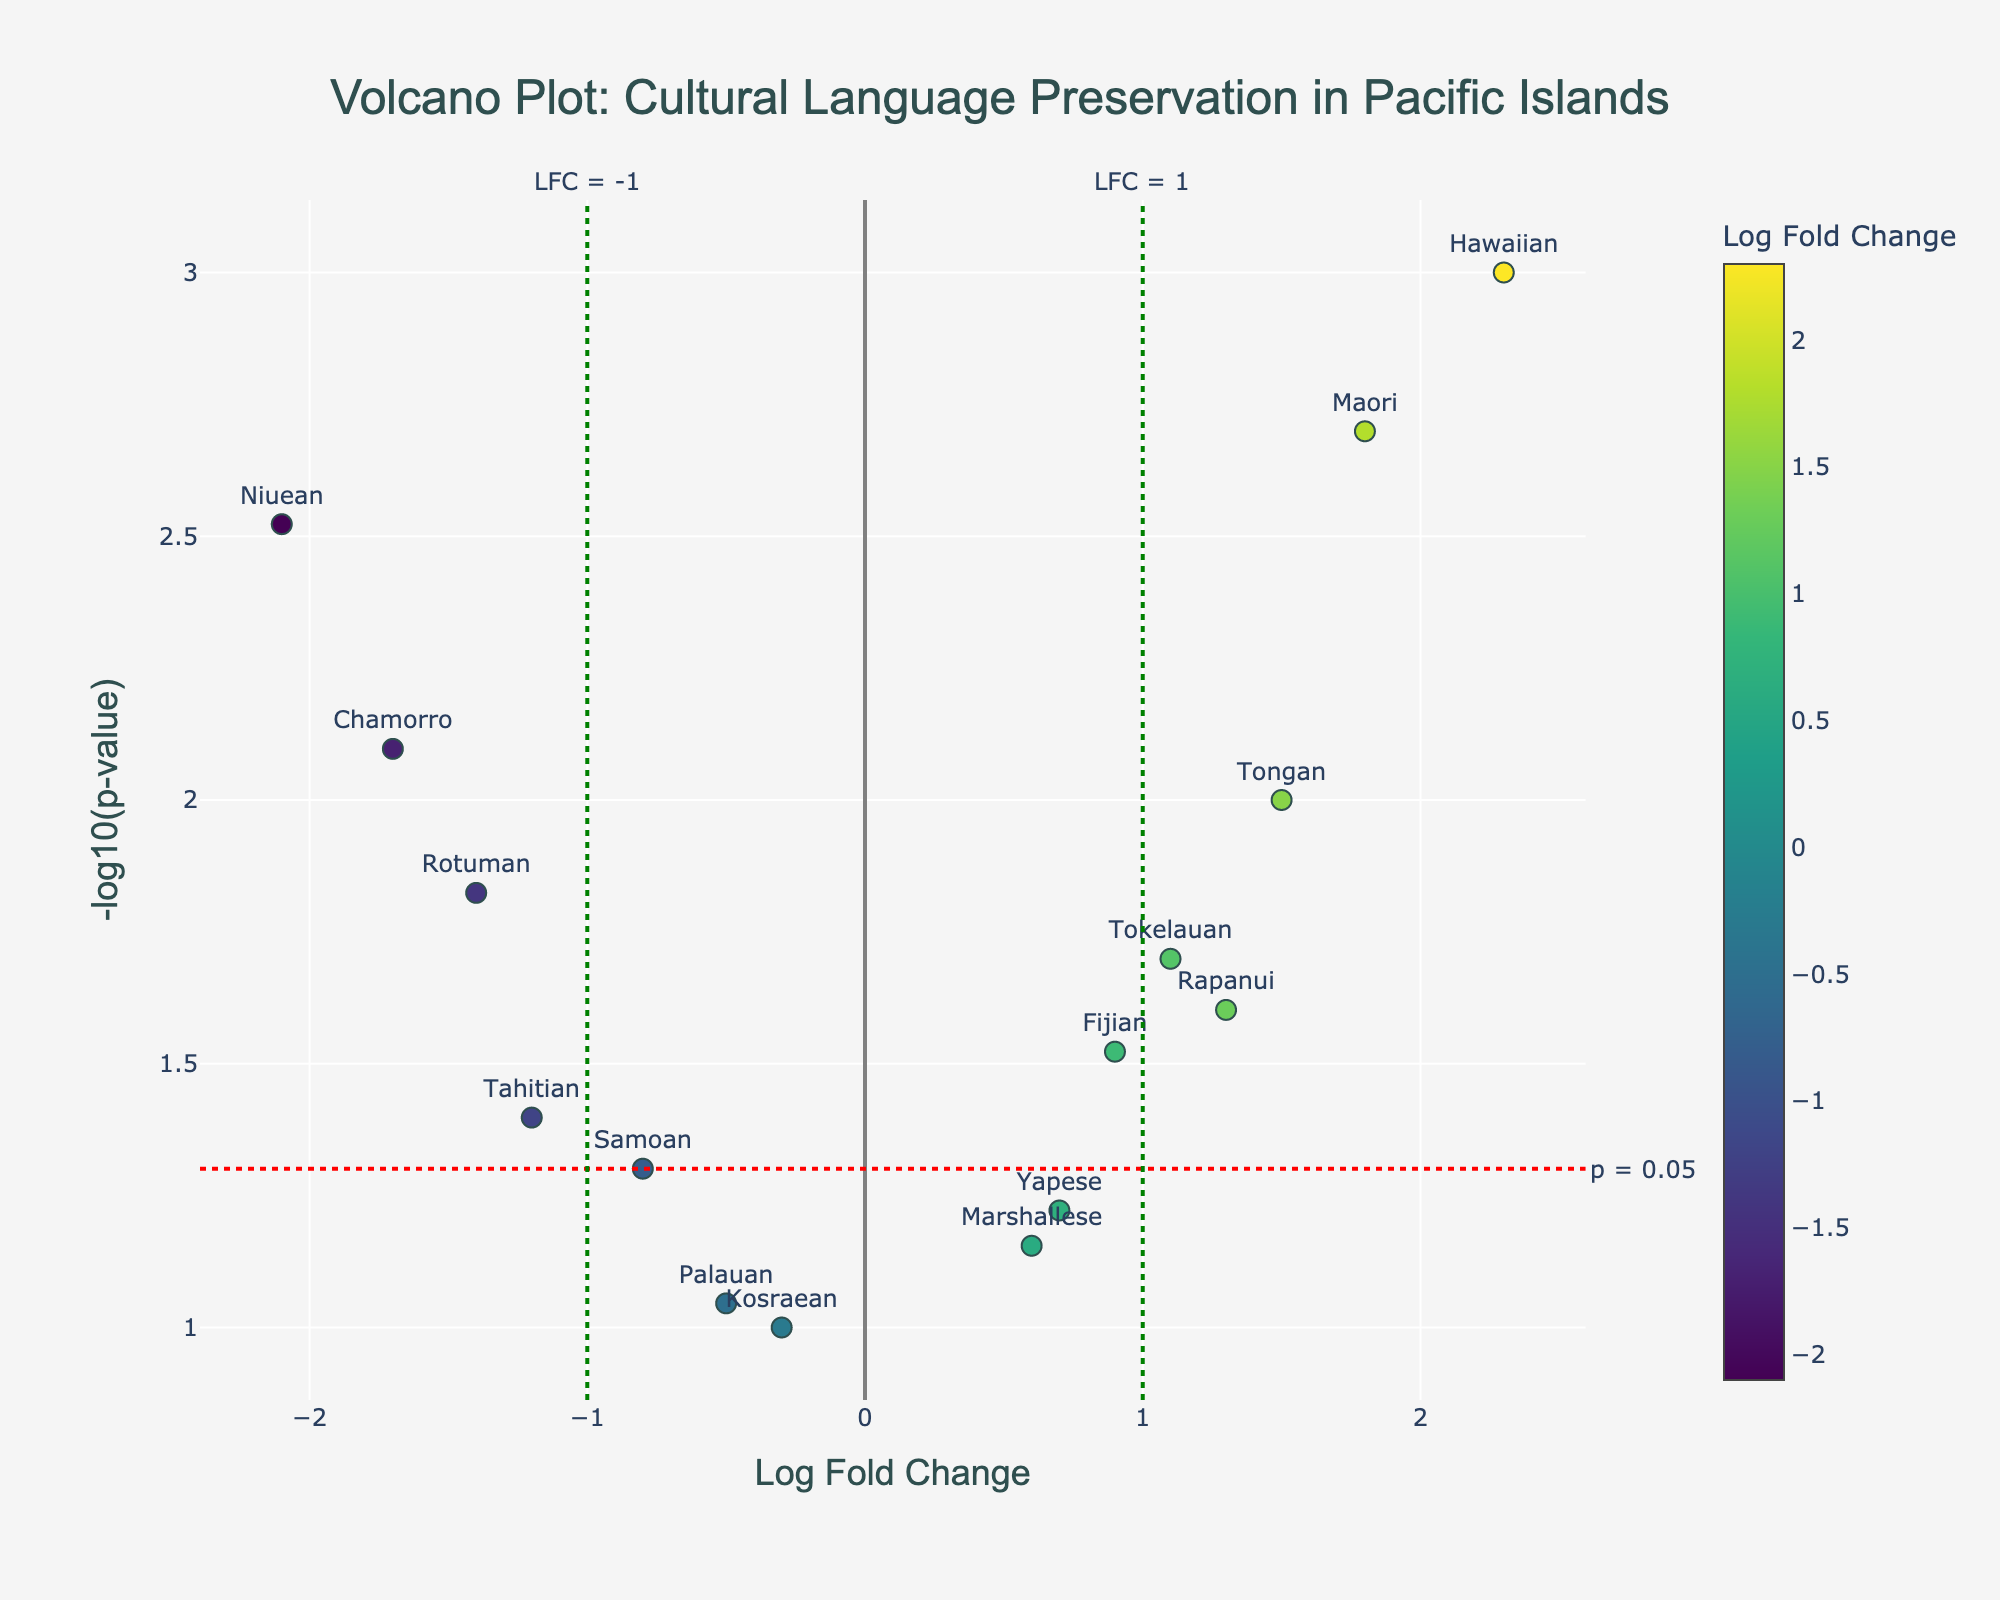What does the title of the plot say? The title of the plot is located at the top center of the figure in large, bold text. It provides a summary of what the plot is about. In this case, it tells us the plot represents "Cultural Language Preservation in Pacific Islands".
Answer: Cultural Language Preservation in Pacific Islands What are the axes labels? The labels of the axes are crucial for understanding what the data points represent. In this case, the x-axis is labeled "Log Fold Change," and the y-axis is labeled "-log10(p-value)".
Answer: Log Fold Change (x-axis), -log10(p-value) (y-axis) How many languages are represented in the plot? Each marker represents one language, and the labels on the plot can be counted.
Answer: 15 What's the significance threshold line represented on the y-axis? The figure includes a horizontal line denoted with a label. This line is typically used to mark a statistical significance threshold, which in this case is for the p-value. The line is drawn at y = -log10(0.05).
Answer: p = 0.05 Which language has the highest Log Fold Change and what is its p-value? First, identify the language with the highest x-coordinate value (Log Fold Change). This value is associated with the language "Hawaiian". The hover text for "Hawaiian" shows its p-value.
Answer: Hawaiian, 0.001 Which languages are considered thriving (Log Fold Change > 1)? Thriving languages are those with Log Fold Change greater than 1. By observing the data points to the right of the vertical green line at x = 1, we identify the languages.
Answer: Hawaiian, Tongan, Maori, Rapanui, Tokelauan What languages have a p-value less than 0.01? Languages with p-value less than 0.01 are represented by the points that lie above the horizontal red line at y = -log10(0.01) on the plot. These languages are identified by their markers above this line.
Answer: Hawaiian, Maori, Chamorro, Niuean Which language has the most negative Log Fold Change? The language with the most negative Log Fold Change is the one located furthest to the left on the x-axis.
Answer: Niuean How many languages are above the significance threshold and also have a thriving Log Fold Change? Languages that meet these criteria are those above the horizontal red line (p-value < 0.05) and to the right of the vertical green line (Log Fold Change > 1). The points that meet both criteria belong to this group.
Answer: 3 (Hawaiian, Maori, Tokelauan) Identify a language that is not significantly changed but has a higher Log Fold Change. This involves finding a language above the significance threshold (y = -log10(0.05)) but with a Log Fold Change greater than 0. The hover text and positions indicate this is "Marshallese".
Answer: Marshallese 